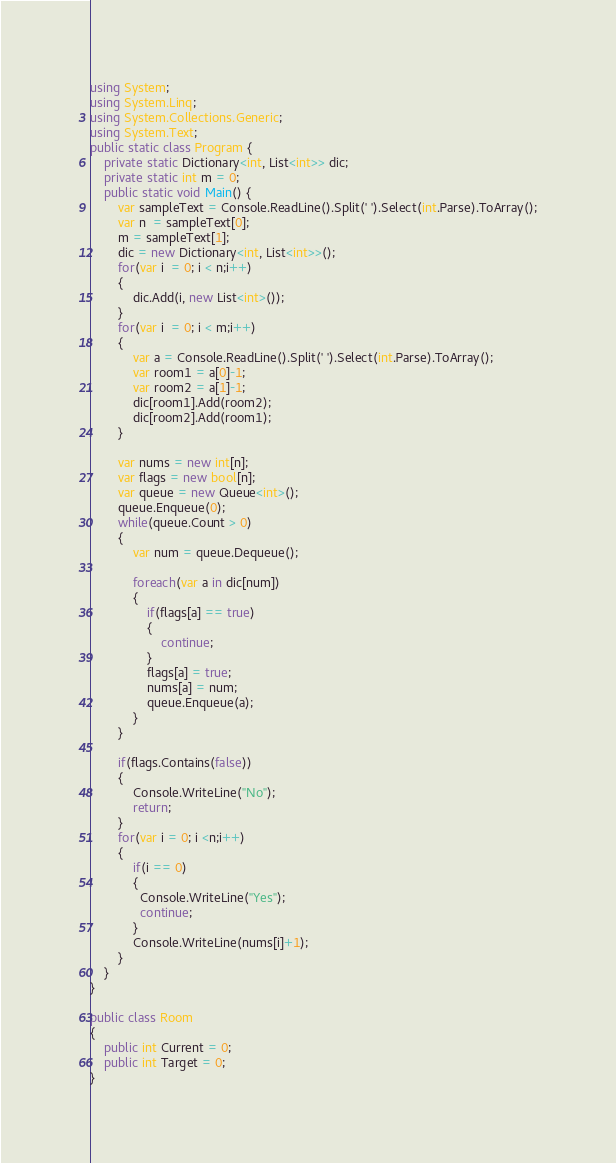<code> <loc_0><loc_0><loc_500><loc_500><_C#_>using System;
using System.Linq;
using System.Collections.Generic;
using System.Text;
public static class Program {
    private static Dictionary<int, List<int>> dic;
    private static int m = 0;
    public static void Main() {
        var sampleText = Console.ReadLine().Split(' ').Select(int.Parse).ToArray();
        var n  = sampleText[0];
        m = sampleText[1];
        dic = new Dictionary<int, List<int>>();
        for(var i  = 0; i < n;i++)
        {
            dic.Add(i, new List<int>());
        }
        for(var i  = 0; i < m;i++)
        {
            var a = Console.ReadLine().Split(' ').Select(int.Parse).ToArray();
            var room1 = a[0]-1;
            var room2 = a[1]-1;
            dic[room1].Add(room2);
            dic[room2].Add(room1);
        }
      
        var nums = new int[n];
        var flags = new bool[n];
        var queue = new Queue<int>();
        queue.Enqueue(0);
        while(queue.Count > 0)
        {
            var num = queue.Dequeue();
            
            foreach(var a in dic[num])
            {
                if(flags[a] == true)
                {
                    continue;
                }
                flags[a] = true;
                nums[a] = num;
                queue.Enqueue(a);
            }  
        }
        
        if(flags.Contains(false))
        {
            Console.WriteLine("No");
            return;
        }
        for(var i = 0; i <n;i++)
        {
            if(i == 0)
            {
              Console.WriteLine("Yes");
              continue;
            }
            Console.WriteLine(nums[i]+1);
        }
    }
}

public class Room
{
    public int Current = 0;
    public int Target = 0;
}
</code> 